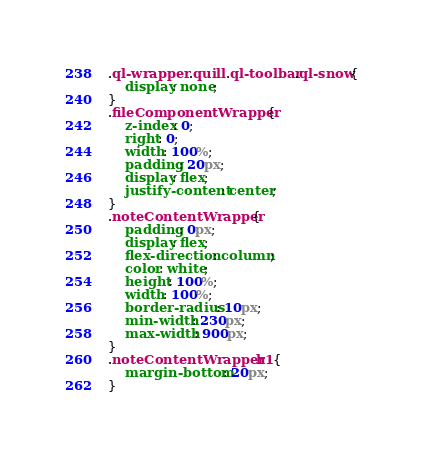<code> <loc_0><loc_0><loc_500><loc_500><_CSS_>.ql-wrapper .quill .ql-toolbar.ql-snow{
	display: none;
}
.fileComponentWrapper{
	z-index: 0;
	right: 0;  
	width: 100%;
	padding: 20px;
	display: flex;
	justify-content: center;
}
.noteContentWrapper{
	padding: 0px;
	display: flex;
	flex-direction: column;
	color: white;
	height: 100%;
	width: 100%; 
	border-radius: 10px;
	min-width: 230px;
	max-width: 900px;
}
.noteContentWrapper h1{
	margin-bottom: 20px;
}</code> 